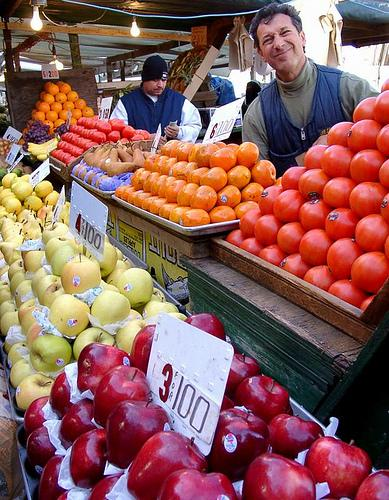What is the name of the red apples? red delicious 